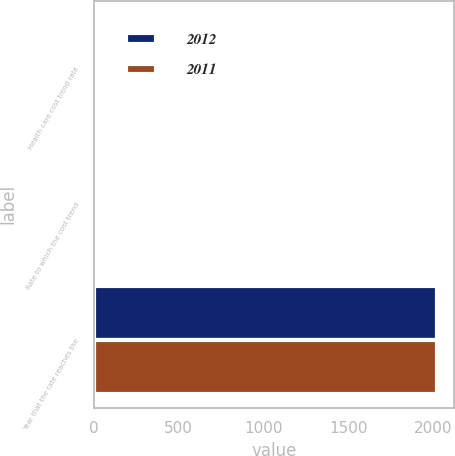Convert chart to OTSL. <chart><loc_0><loc_0><loc_500><loc_500><stacked_bar_chart><ecel><fcel>Health care cost trend rate<fcel>Rate to which the cost trend<fcel>Year that the rate reaches the<nl><fcel>2012<fcel>8.5<fcel>5.2<fcel>2019<nl><fcel>2011<fcel>8.5<fcel>5.2<fcel>2019<nl></chart> 